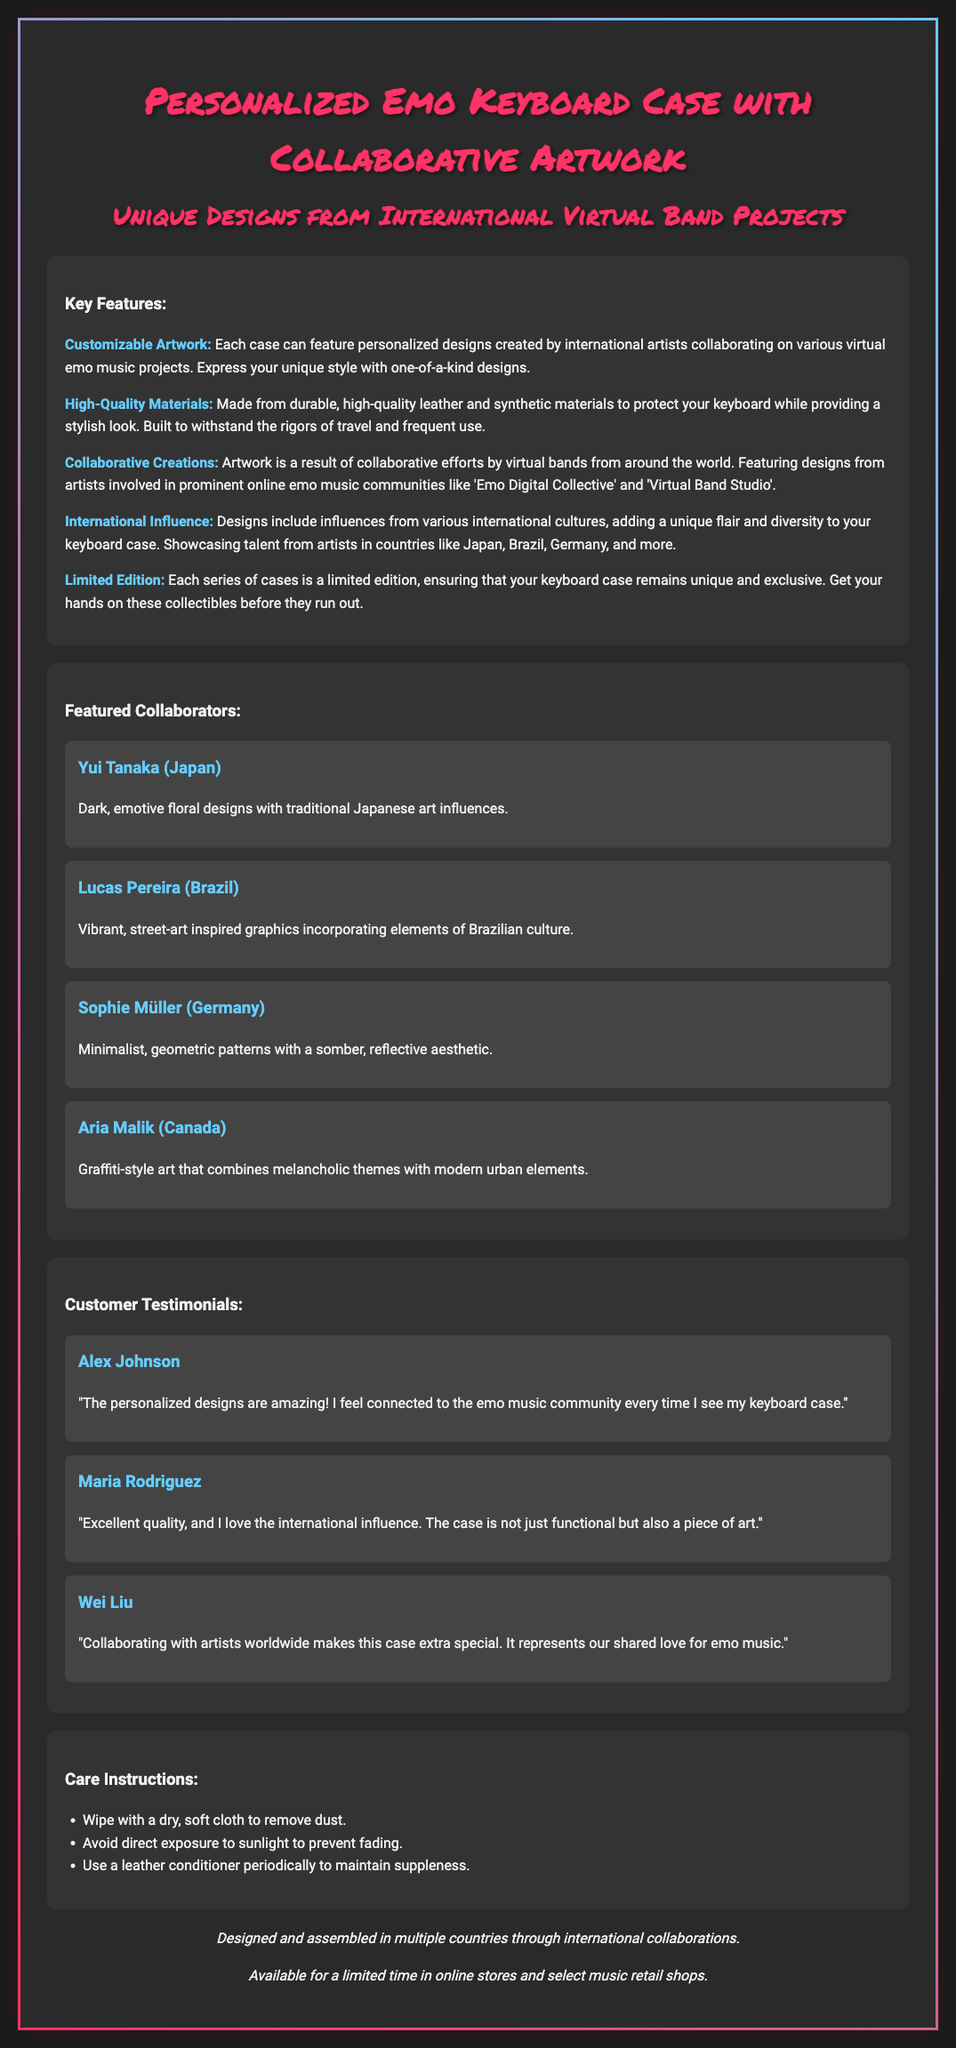what is the product being featured? The product being featured is a personalized emo keyboard case with collaborative artwork.
Answer: personalized emo keyboard case who are the featured collaborators? The document lists artists who have collaborated on the keyboard case's designs.
Answer: Yui Tanaka, Lucas Pereira, Sophie Müller, Aria Malik what is the primary influence in the designs? The designs are influenced by various international cultures, showcasing diverse artistic styles.
Answer: international cultures how is the product's quality described? The document mentions the materials used to create the keyboard case and their durability.
Answer: high-quality materials what type of artwork can customers expect? The artwork on the cases includes personalized designs created through international collaboration.
Answer: customizable artwork how often are the designs updated or released? The document indicates that these cases are produced in limited editions, signifying a periodic release cycle.
Answer: limited edition which countries are represented by the collaborators? The featured artists hail from different countries, reflecting a broad international influence.
Answer: Japan, Brazil, Germany, Canada what do customers say about the product quality? Testimonials from customers highlight their satisfaction with the quality and artistic styles presented.
Answer: excellent quality 